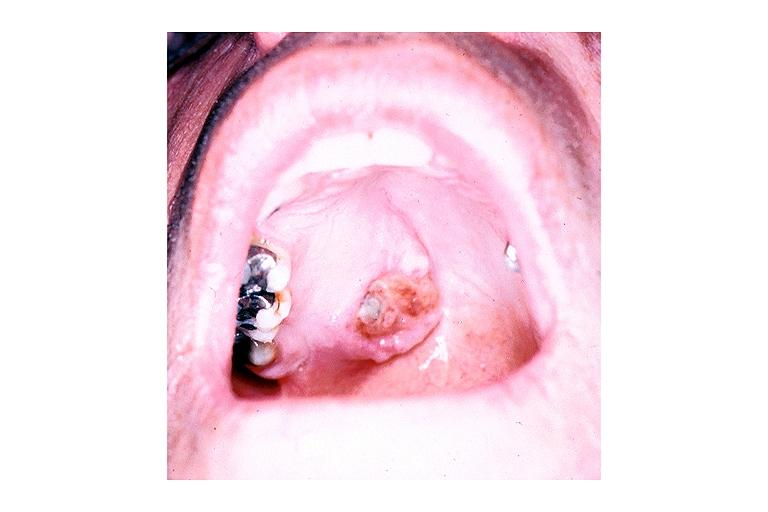does male reproductive show adenoid cystic carcinoma?
Answer the question using a single word or phrase. No 